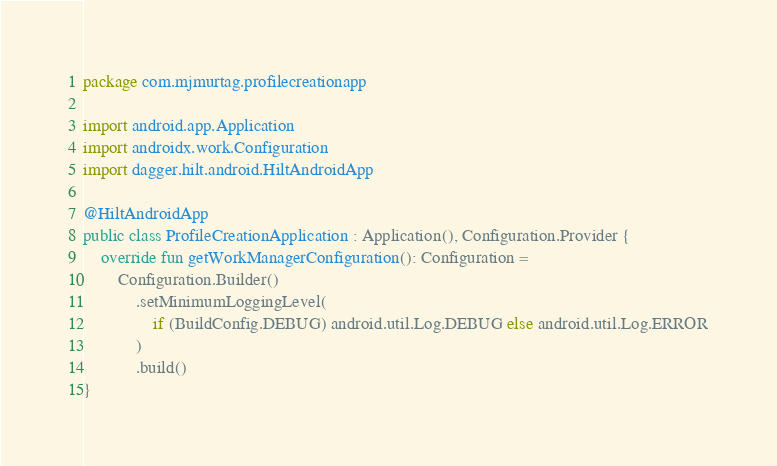<code> <loc_0><loc_0><loc_500><loc_500><_Kotlin_>package com.mjmurtag.profilecreationapp

import android.app.Application
import androidx.work.Configuration
import dagger.hilt.android.HiltAndroidApp

@HiltAndroidApp
public class ProfileCreationApplication : Application(), Configuration.Provider {
    override fun getWorkManagerConfiguration(): Configuration =
        Configuration.Builder()
            .setMinimumLoggingLevel(
                if (BuildConfig.DEBUG) android.util.Log.DEBUG else android.util.Log.ERROR
            )
            .build()
}
</code> 